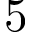Convert formula to latex. <formula><loc_0><loc_0><loc_500><loc_500>5</formula> 